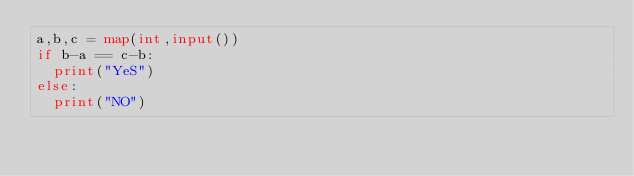<code> <loc_0><loc_0><loc_500><loc_500><_Python_>a,b,c = map(int,input())
if b-a == c-b:
  print("YeS")
else:
  print("NO")</code> 